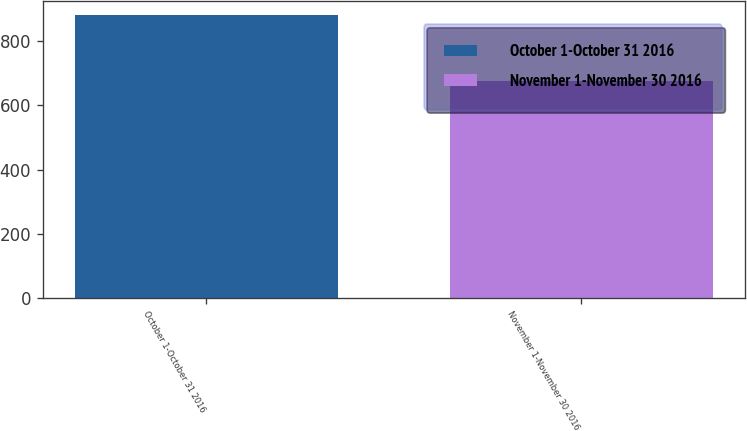Convert chart. <chart><loc_0><loc_0><loc_500><loc_500><bar_chart><fcel>October 1-October 31 2016<fcel>November 1-November 30 2016<nl><fcel>881<fcel>677.1<nl></chart> 